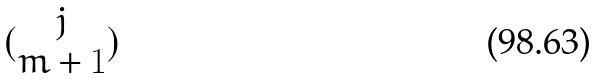<formula> <loc_0><loc_0><loc_500><loc_500>( \begin{matrix} j \\ m + 1 \end{matrix} )</formula> 